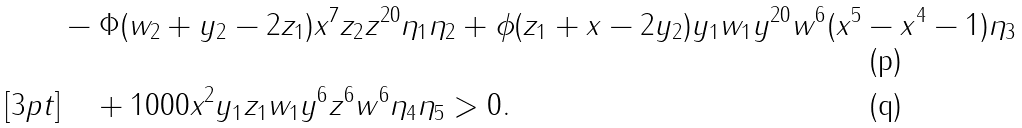<formula> <loc_0><loc_0><loc_500><loc_500>& - \Phi ( w _ { 2 } + y _ { 2 } - 2 z _ { 1 } ) x ^ { 7 } z _ { 2 } z ^ { 2 0 } \eta _ { 1 } \eta _ { 2 } + \phi ( z _ { 1 } + x - 2 y _ { 2 } ) y _ { 1 } w _ { 1 } y ^ { 2 0 } w ^ { 6 } ( x ^ { 5 } - x ^ { 4 } - 1 ) \eta _ { 3 } \\ [ 3 p t ] & \quad + 1 0 0 0 x ^ { 2 } y _ { 1 } z _ { 1 } w _ { 1 } y ^ { 6 } z ^ { 6 } w ^ { 6 } \eta _ { 4 } \eta _ { 5 } > 0 .</formula> 